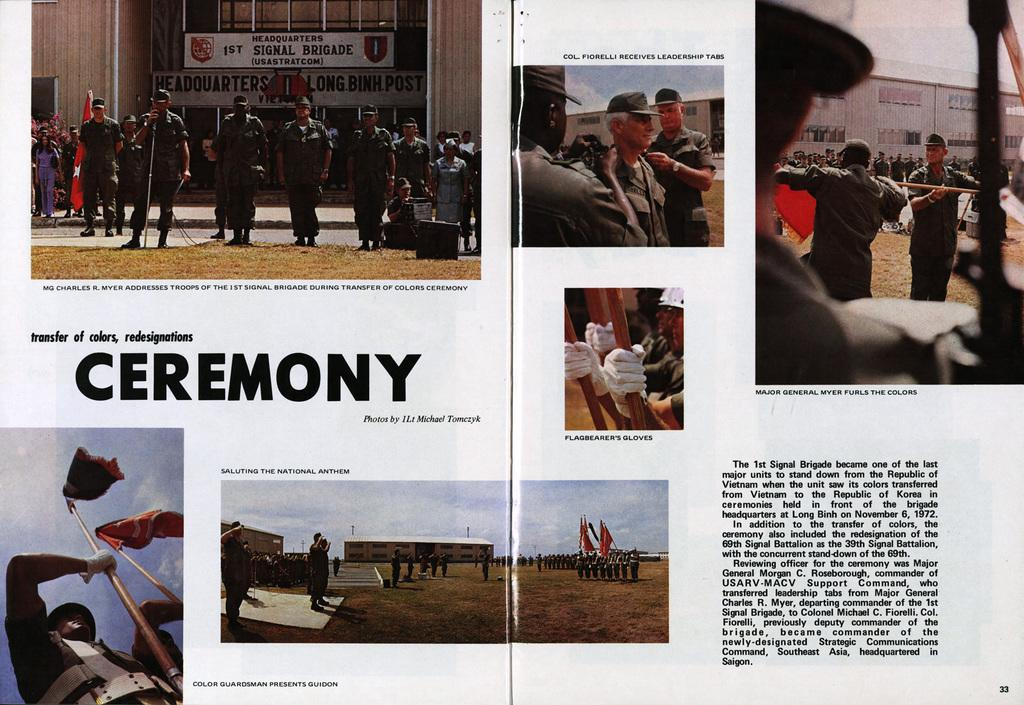What is the main subject of the image? The main subject of the image is an article. What can be seen on the article? Something is written on the article. Who or what else is present in the image? There are people, boards, the sky, flags, poles, buildings, and other objects in the image. Can you tell me how many locks are visible on the article in the image? There are no locks present on the article or in the image. What type of butter is being used by the people in the image? There is no butter present in the image, and the people's actions are not described. 